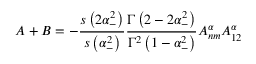Convert formula to latex. <formula><loc_0><loc_0><loc_500><loc_500>A + B = - \frac { s \left ( 2 \alpha _ { - } ^ { 2 } \right ) } { s \left ( \alpha _ { - } ^ { 2 } \right ) } \frac { \Gamma \left ( 2 - 2 \alpha _ { - } ^ { 2 } \right ) } { \Gamma ^ { 2 } \left ( 1 - \alpha _ { - } ^ { 2 } \right ) } A _ { n m } ^ { \alpha } A _ { 1 2 } ^ { \alpha }</formula> 